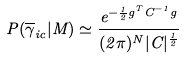<formula> <loc_0><loc_0><loc_500><loc_500>P ( \overline { \gamma } _ { i c } | M ) \simeq \frac { e ^ { - \frac { 1 } { 2 } g ^ { T } C ^ { - 1 } g } } { ( 2 \pi ) ^ { N } | C | ^ { \frac { 1 } { 2 } } }</formula> 